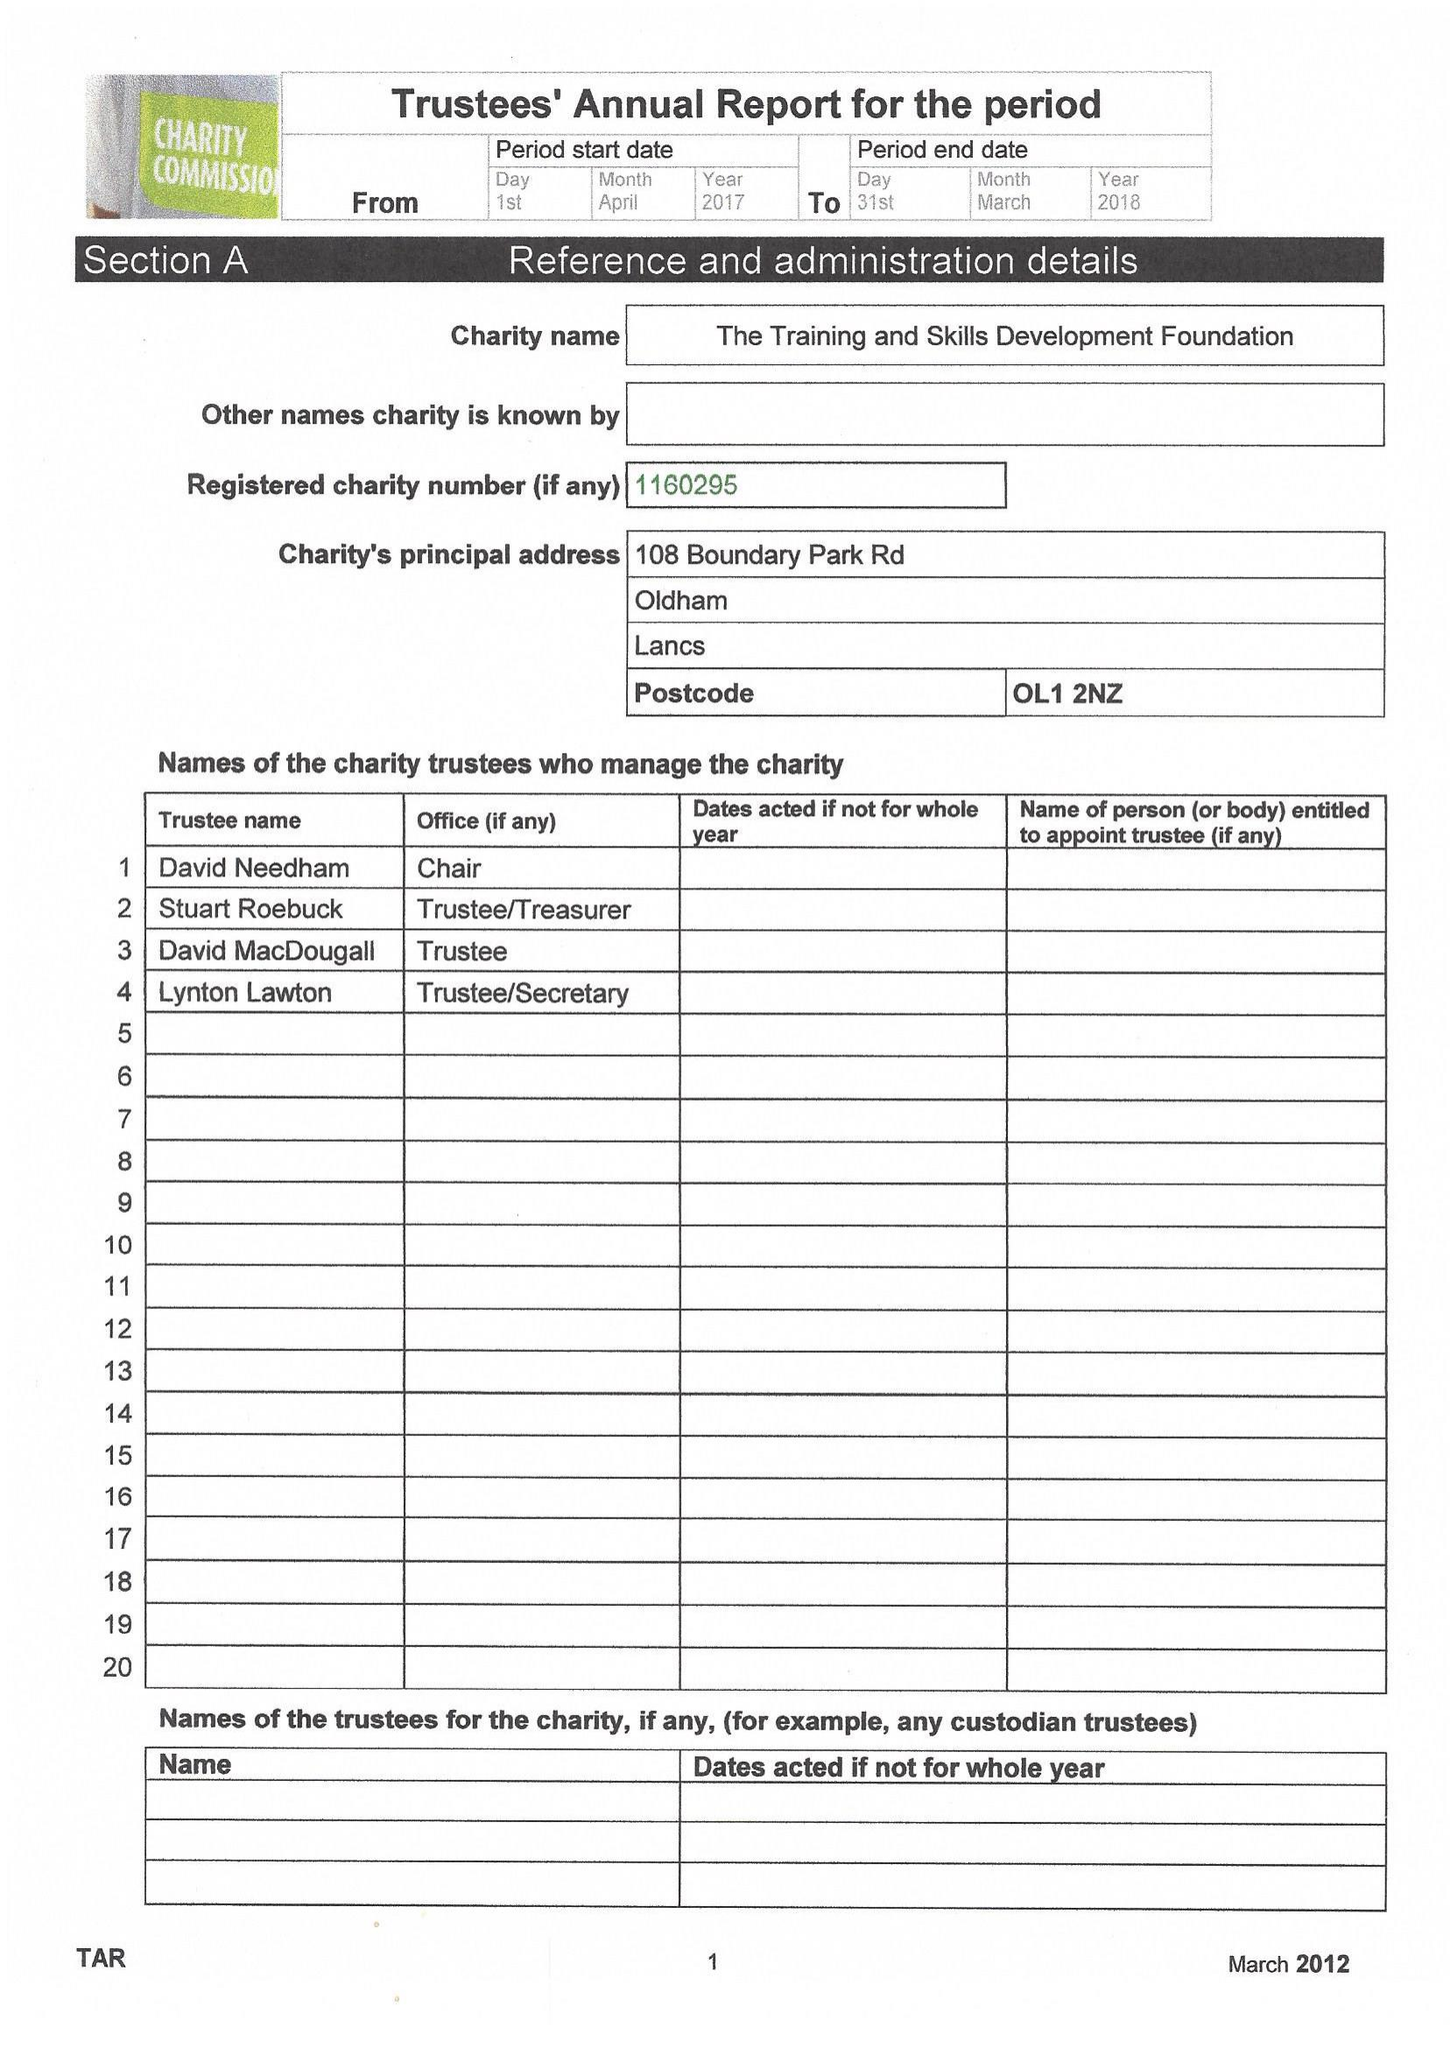What is the value for the address__post_town?
Answer the question using a single word or phrase. OLDHAM 